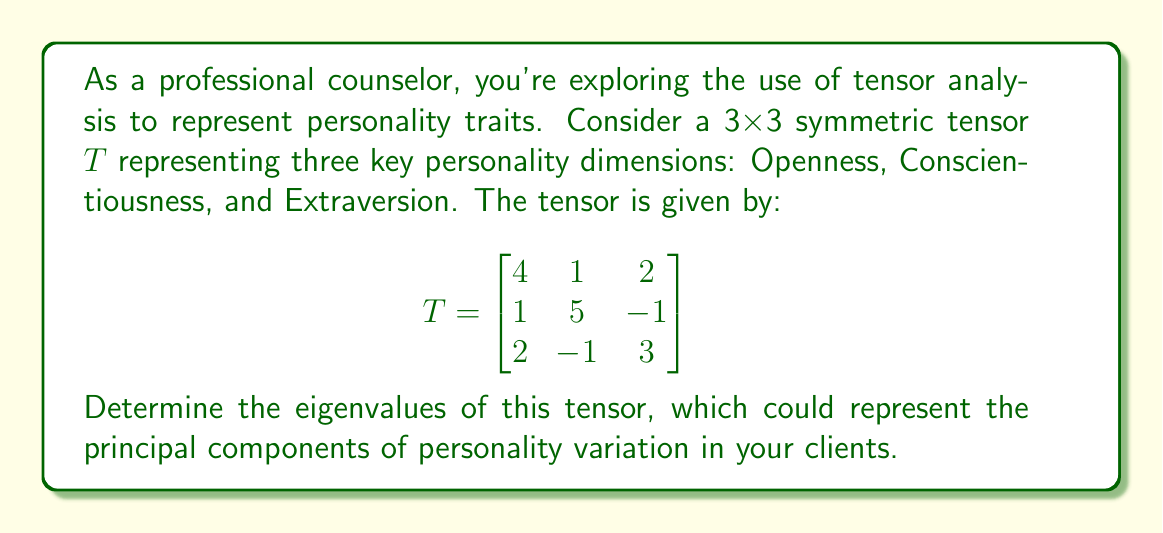Teach me how to tackle this problem. To find the eigenvalues of the tensor $T$, we need to solve the characteristic equation:

1) First, we set up the equation $\det(T - \lambda I) = 0$, where $I$ is the 3x3 identity matrix and $\lambda$ represents the eigenvalues:

   $$\det\begin{bmatrix}
   4-\lambda & 1 & 2 \\
   1 & 5-\lambda & -1 \\
   2 & -1 & 3-\lambda
   \end{bmatrix} = 0$$

2) Expand the determinant:
   $$(4-\lambda)[(5-\lambda)(3-\lambda) - (-1)(-1)] - 1[1(3-\lambda) - 2(-1)] + 2[1(-1) - (5-\lambda)(2)] = 0$$

3) Simplify:
   $$(4-\lambda)[(5-\lambda)(3-\lambda) - 1] - [3-\lambda + 2] + 2[-1 - (5-\lambda)(2)] = 0$$
   
   $$(4-\lambda)(15-8\lambda+\lambda^2-1) - (5-\lambda) - 2(-1-10+2\lambda) = 0$$

4) Expand further:
   $$60-32\lambda+4\lambda^2-4-15\lambda+8\lambda^2-\lambda^3+\lambda - 5 + \lambda + 2 + 20 - 4\lambda = 0$$

5) Collect terms:
   $$-\lambda^3 + 12\lambda^2 - 42\lambda + 73 = 0$$

6) This is a cubic equation. While it can be solved analytically, it's complex. Using numerical methods or a calculator, we can find the roots.

The eigenvalues are approximately:
$\lambda_1 \approx 7.0404$
$\lambda_2 \approx 3.7453$
$\lambda_3 \approx 1.2143$

These eigenvalues represent the principal components of variation in the personality traits, which could be interpreted as the most significant underlying factors in your clients' personalities.
Answer: $\lambda_1 \approx 7.0404$, $\lambda_2 \approx 3.7453$, $\lambda_3 \approx 1.2143$ 